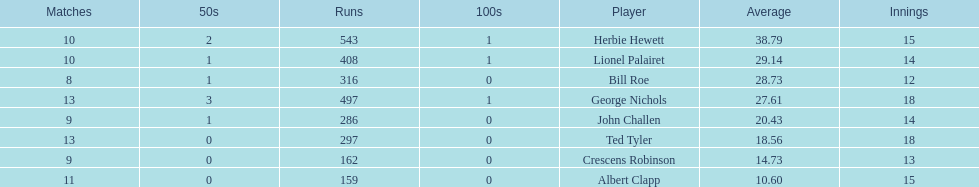Which player scored the lowest amount of runs? Albert Clapp. 